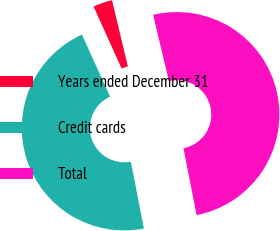<chart> <loc_0><loc_0><loc_500><loc_500><pie_chart><fcel>Years ended December 31<fcel>Credit cards<fcel>Total<nl><fcel>3.04%<fcel>46.31%<fcel>50.65%<nl></chart> 